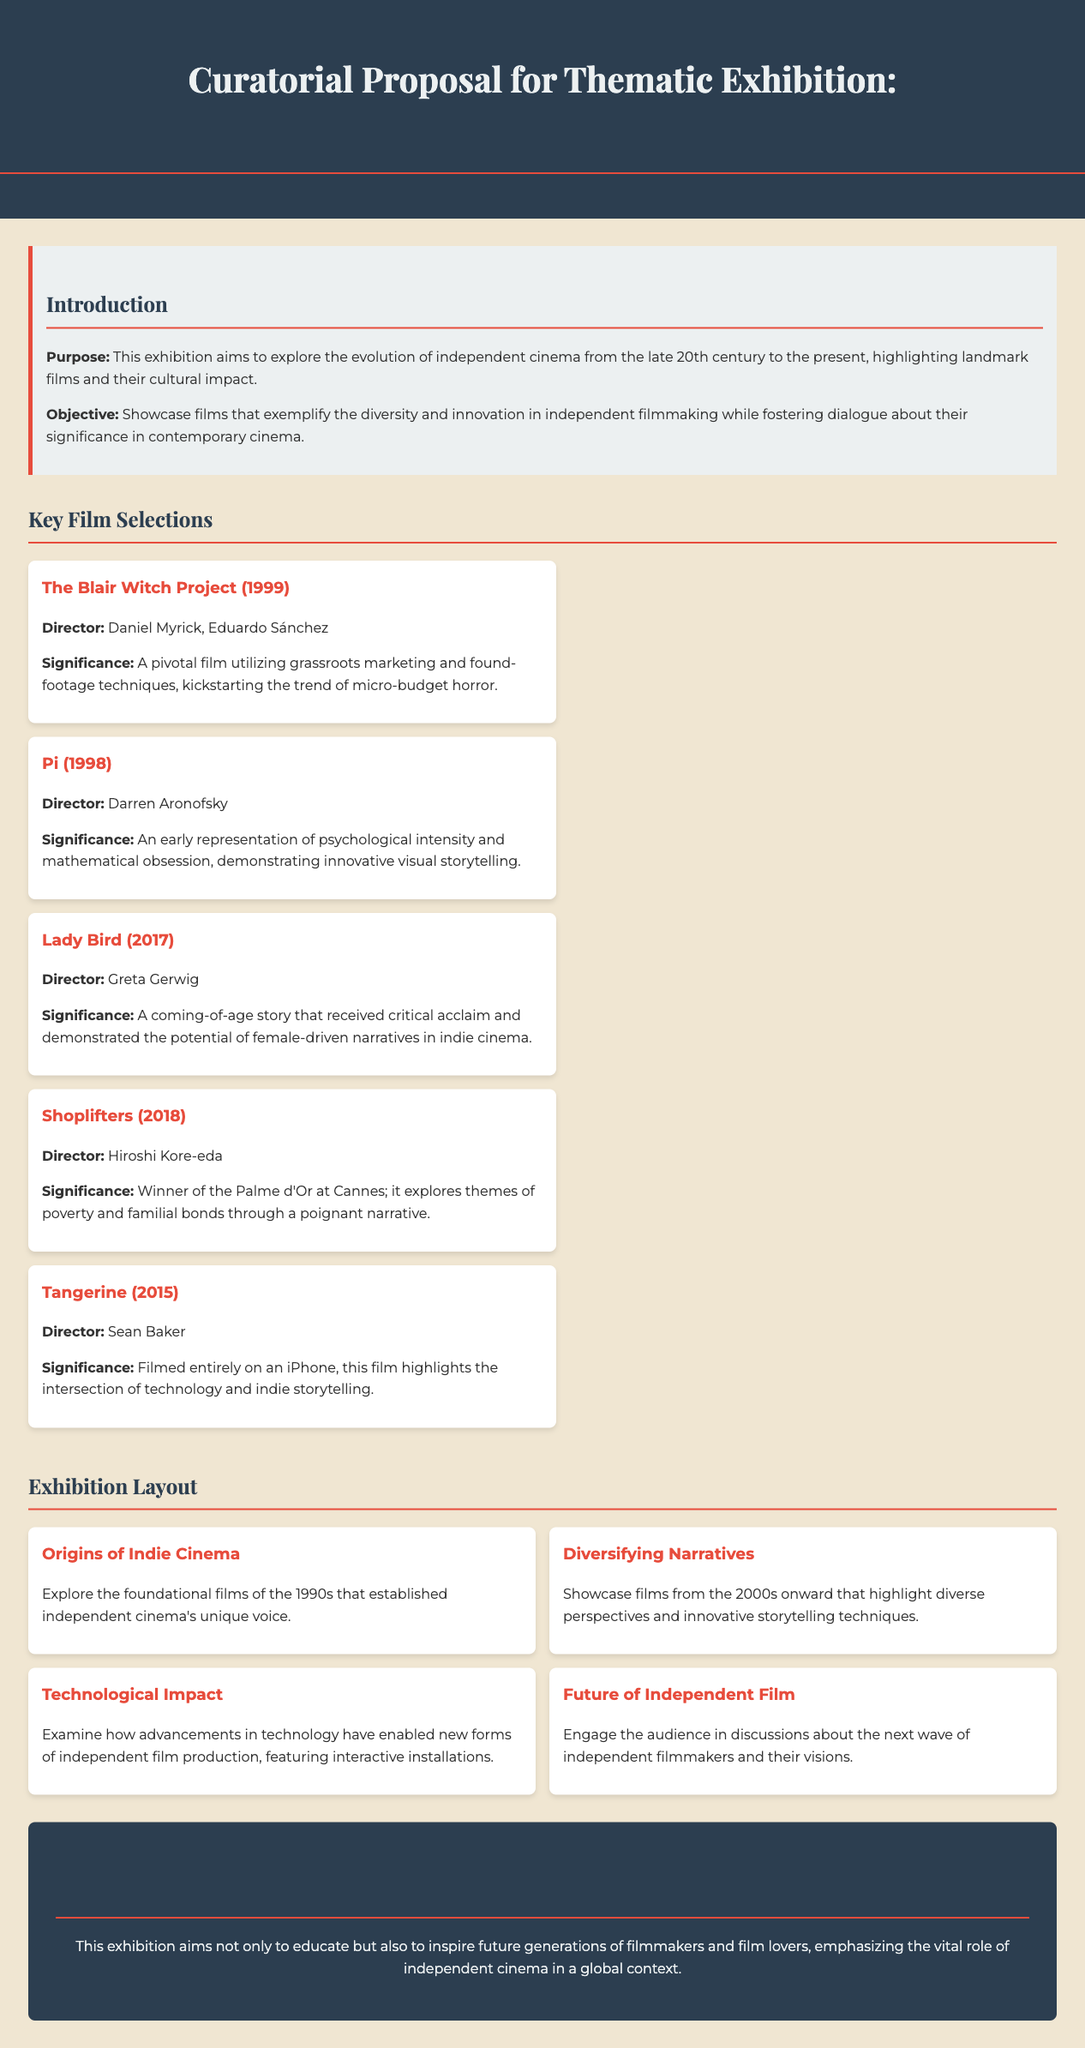What is the purpose of the exhibition? The purpose of the exhibition is to explore the evolution of independent cinema from the late 20th century to the present, highlighting landmark films and their cultural impact.
Answer: To explore the evolution of independent cinema Who directed "Lady Bird"? "Lady Bird" was directed by Greta Gerwig as stated in the key film selections.
Answer: Greta Gerwig What film is mentioned as utilizing found-footage techniques? "The Blair Witch Project" is mentioned as utilizing grassroots marketing and found-footage techniques.
Answer: The Blair Witch Project How many film cards are listed in the document? The document lists five film cards under key film selections, showcasing key independent films.
Answer: Five What is the title of the section focusing on technological advancements? The section focusing on technological advancements is titled "Technological Impact."
Answer: Technological Impact Which film won the Palme d'Or at Cannes? "Shoplifters" is noted as the film that won the Palme d'Or at Cannes.
Answer: Shoplifters What theme is explored in the section titled "Diversitying Narratives"? The section titled "Diversitying Narratives" explores films from the 2000s onward that highlight diverse perspectives and innovative storytelling techniques.
Answer: Diverse perspectives and innovative storytelling techniques What year was "Tangerine" released? "Tangerine" was released in 2015, as indicated in the key film selections.
Answer: 2015 What is the significance of "Pi"? "Pi" is significant as an early representation of psychological intensity and mathematical obsession.
Answer: Psychological intensity and mathematical obsession 